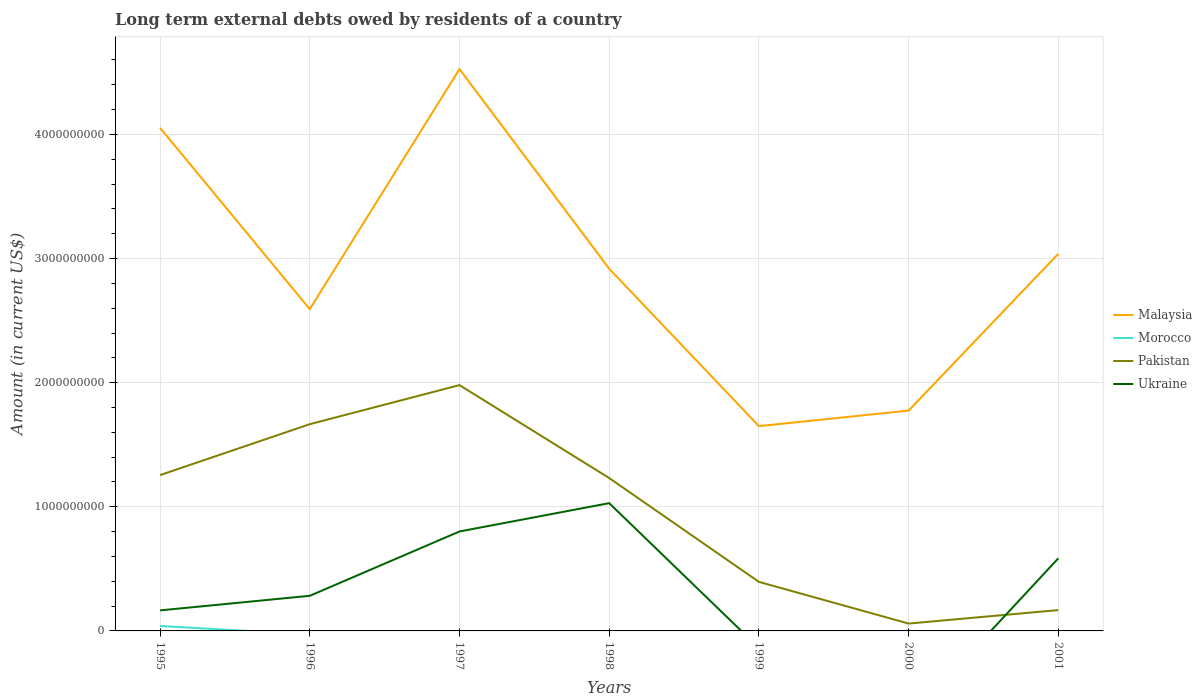Across all years, what is the maximum amount of long-term external debts owed by residents in Pakistan?
Give a very brief answer. 5.93e+07. What is the total amount of long-term external debts owed by residents in Pakistan in the graph?
Keep it short and to the point. 1.17e+09. What is the difference between the highest and the second highest amount of long-term external debts owed by residents in Ukraine?
Offer a terse response. 1.03e+09. How many years are there in the graph?
Provide a short and direct response. 7. Are the values on the major ticks of Y-axis written in scientific E-notation?
Provide a succinct answer. No. Does the graph contain any zero values?
Offer a terse response. Yes. Does the graph contain grids?
Give a very brief answer. Yes. Where does the legend appear in the graph?
Offer a terse response. Center right. What is the title of the graph?
Provide a succinct answer. Long term external debts owed by residents of a country. Does "Romania" appear as one of the legend labels in the graph?
Give a very brief answer. No. What is the Amount (in current US$) in Malaysia in 1995?
Ensure brevity in your answer.  4.05e+09. What is the Amount (in current US$) in Morocco in 1995?
Your answer should be very brief. 3.99e+07. What is the Amount (in current US$) in Pakistan in 1995?
Ensure brevity in your answer.  1.26e+09. What is the Amount (in current US$) in Ukraine in 1995?
Offer a terse response. 1.65e+08. What is the Amount (in current US$) in Malaysia in 1996?
Offer a terse response. 2.59e+09. What is the Amount (in current US$) of Morocco in 1996?
Keep it short and to the point. 0. What is the Amount (in current US$) of Pakistan in 1996?
Your answer should be compact. 1.67e+09. What is the Amount (in current US$) in Ukraine in 1996?
Your response must be concise. 2.83e+08. What is the Amount (in current US$) of Malaysia in 1997?
Give a very brief answer. 4.53e+09. What is the Amount (in current US$) of Pakistan in 1997?
Provide a succinct answer. 1.98e+09. What is the Amount (in current US$) of Ukraine in 1997?
Keep it short and to the point. 8.01e+08. What is the Amount (in current US$) of Malaysia in 1998?
Ensure brevity in your answer.  2.92e+09. What is the Amount (in current US$) in Morocco in 1998?
Make the answer very short. 0. What is the Amount (in current US$) of Pakistan in 1998?
Offer a very short reply. 1.23e+09. What is the Amount (in current US$) of Ukraine in 1998?
Provide a short and direct response. 1.03e+09. What is the Amount (in current US$) of Malaysia in 1999?
Offer a very short reply. 1.65e+09. What is the Amount (in current US$) of Pakistan in 1999?
Provide a short and direct response. 3.95e+08. What is the Amount (in current US$) of Ukraine in 1999?
Provide a short and direct response. 0. What is the Amount (in current US$) of Malaysia in 2000?
Ensure brevity in your answer.  1.78e+09. What is the Amount (in current US$) of Morocco in 2000?
Ensure brevity in your answer.  5.96e+06. What is the Amount (in current US$) in Pakistan in 2000?
Give a very brief answer. 5.93e+07. What is the Amount (in current US$) of Ukraine in 2000?
Make the answer very short. 0. What is the Amount (in current US$) in Malaysia in 2001?
Make the answer very short. 3.04e+09. What is the Amount (in current US$) of Morocco in 2001?
Your answer should be compact. 0. What is the Amount (in current US$) in Pakistan in 2001?
Your answer should be compact. 1.68e+08. What is the Amount (in current US$) in Ukraine in 2001?
Keep it short and to the point. 5.85e+08. Across all years, what is the maximum Amount (in current US$) of Malaysia?
Give a very brief answer. 4.53e+09. Across all years, what is the maximum Amount (in current US$) of Morocco?
Offer a terse response. 3.99e+07. Across all years, what is the maximum Amount (in current US$) of Pakistan?
Provide a succinct answer. 1.98e+09. Across all years, what is the maximum Amount (in current US$) in Ukraine?
Keep it short and to the point. 1.03e+09. Across all years, what is the minimum Amount (in current US$) of Malaysia?
Offer a terse response. 1.65e+09. Across all years, what is the minimum Amount (in current US$) in Pakistan?
Keep it short and to the point. 5.93e+07. Across all years, what is the minimum Amount (in current US$) of Ukraine?
Give a very brief answer. 0. What is the total Amount (in current US$) of Malaysia in the graph?
Your answer should be very brief. 2.06e+1. What is the total Amount (in current US$) of Morocco in the graph?
Provide a short and direct response. 4.59e+07. What is the total Amount (in current US$) in Pakistan in the graph?
Your answer should be very brief. 6.76e+09. What is the total Amount (in current US$) of Ukraine in the graph?
Offer a terse response. 2.86e+09. What is the difference between the Amount (in current US$) in Malaysia in 1995 and that in 1996?
Provide a succinct answer. 1.46e+09. What is the difference between the Amount (in current US$) of Pakistan in 1995 and that in 1996?
Your answer should be compact. -4.10e+08. What is the difference between the Amount (in current US$) of Ukraine in 1995 and that in 1996?
Keep it short and to the point. -1.17e+08. What is the difference between the Amount (in current US$) in Malaysia in 1995 and that in 1997?
Ensure brevity in your answer.  -4.73e+08. What is the difference between the Amount (in current US$) of Pakistan in 1995 and that in 1997?
Give a very brief answer. -7.25e+08. What is the difference between the Amount (in current US$) in Ukraine in 1995 and that in 1997?
Provide a succinct answer. -6.36e+08. What is the difference between the Amount (in current US$) in Malaysia in 1995 and that in 1998?
Keep it short and to the point. 1.14e+09. What is the difference between the Amount (in current US$) of Pakistan in 1995 and that in 1998?
Offer a terse response. 2.37e+07. What is the difference between the Amount (in current US$) in Ukraine in 1995 and that in 1998?
Your response must be concise. -8.64e+08. What is the difference between the Amount (in current US$) in Malaysia in 1995 and that in 1999?
Provide a succinct answer. 2.40e+09. What is the difference between the Amount (in current US$) in Pakistan in 1995 and that in 1999?
Provide a short and direct response. 8.60e+08. What is the difference between the Amount (in current US$) of Malaysia in 1995 and that in 2000?
Offer a very short reply. 2.28e+09. What is the difference between the Amount (in current US$) in Morocco in 1995 and that in 2000?
Offer a terse response. 3.40e+07. What is the difference between the Amount (in current US$) in Pakistan in 1995 and that in 2000?
Offer a terse response. 1.20e+09. What is the difference between the Amount (in current US$) in Malaysia in 1995 and that in 2001?
Keep it short and to the point. 1.01e+09. What is the difference between the Amount (in current US$) of Pakistan in 1995 and that in 2001?
Provide a succinct answer. 1.09e+09. What is the difference between the Amount (in current US$) of Ukraine in 1995 and that in 2001?
Offer a terse response. -4.19e+08. What is the difference between the Amount (in current US$) in Malaysia in 1996 and that in 1997?
Your answer should be compact. -1.93e+09. What is the difference between the Amount (in current US$) in Pakistan in 1996 and that in 1997?
Your response must be concise. -3.15e+08. What is the difference between the Amount (in current US$) of Ukraine in 1996 and that in 1997?
Offer a terse response. -5.18e+08. What is the difference between the Amount (in current US$) of Malaysia in 1996 and that in 1998?
Keep it short and to the point. -3.25e+08. What is the difference between the Amount (in current US$) of Pakistan in 1996 and that in 1998?
Provide a short and direct response. 4.34e+08. What is the difference between the Amount (in current US$) in Ukraine in 1996 and that in 1998?
Provide a short and direct response. -7.46e+08. What is the difference between the Amount (in current US$) in Malaysia in 1996 and that in 1999?
Offer a very short reply. 9.43e+08. What is the difference between the Amount (in current US$) of Pakistan in 1996 and that in 1999?
Give a very brief answer. 1.27e+09. What is the difference between the Amount (in current US$) of Malaysia in 1996 and that in 2000?
Your answer should be very brief. 8.18e+08. What is the difference between the Amount (in current US$) of Pakistan in 1996 and that in 2000?
Offer a very short reply. 1.61e+09. What is the difference between the Amount (in current US$) of Malaysia in 1996 and that in 2001?
Make the answer very short. -4.46e+08. What is the difference between the Amount (in current US$) in Pakistan in 1996 and that in 2001?
Your answer should be very brief. 1.50e+09. What is the difference between the Amount (in current US$) in Ukraine in 1996 and that in 2001?
Give a very brief answer. -3.02e+08. What is the difference between the Amount (in current US$) in Malaysia in 1997 and that in 1998?
Provide a succinct answer. 1.61e+09. What is the difference between the Amount (in current US$) of Pakistan in 1997 and that in 1998?
Keep it short and to the point. 7.49e+08. What is the difference between the Amount (in current US$) in Ukraine in 1997 and that in 1998?
Your answer should be compact. -2.28e+08. What is the difference between the Amount (in current US$) of Malaysia in 1997 and that in 1999?
Ensure brevity in your answer.  2.88e+09. What is the difference between the Amount (in current US$) in Pakistan in 1997 and that in 1999?
Provide a succinct answer. 1.59e+09. What is the difference between the Amount (in current US$) of Malaysia in 1997 and that in 2000?
Offer a terse response. 2.75e+09. What is the difference between the Amount (in current US$) of Pakistan in 1997 and that in 2000?
Offer a terse response. 1.92e+09. What is the difference between the Amount (in current US$) of Malaysia in 1997 and that in 2001?
Your answer should be very brief. 1.49e+09. What is the difference between the Amount (in current US$) of Pakistan in 1997 and that in 2001?
Your answer should be very brief. 1.81e+09. What is the difference between the Amount (in current US$) of Ukraine in 1997 and that in 2001?
Ensure brevity in your answer.  2.16e+08. What is the difference between the Amount (in current US$) of Malaysia in 1998 and that in 1999?
Provide a short and direct response. 1.27e+09. What is the difference between the Amount (in current US$) in Pakistan in 1998 and that in 1999?
Your answer should be compact. 8.37e+08. What is the difference between the Amount (in current US$) in Malaysia in 1998 and that in 2000?
Offer a terse response. 1.14e+09. What is the difference between the Amount (in current US$) of Pakistan in 1998 and that in 2000?
Ensure brevity in your answer.  1.17e+09. What is the difference between the Amount (in current US$) in Malaysia in 1998 and that in 2001?
Your answer should be compact. -1.20e+08. What is the difference between the Amount (in current US$) in Pakistan in 1998 and that in 2001?
Provide a succinct answer. 1.06e+09. What is the difference between the Amount (in current US$) of Ukraine in 1998 and that in 2001?
Your answer should be very brief. 4.44e+08. What is the difference between the Amount (in current US$) of Malaysia in 1999 and that in 2000?
Offer a very short reply. -1.25e+08. What is the difference between the Amount (in current US$) in Pakistan in 1999 and that in 2000?
Ensure brevity in your answer.  3.36e+08. What is the difference between the Amount (in current US$) of Malaysia in 1999 and that in 2001?
Provide a succinct answer. -1.39e+09. What is the difference between the Amount (in current US$) in Pakistan in 1999 and that in 2001?
Your answer should be very brief. 2.27e+08. What is the difference between the Amount (in current US$) of Malaysia in 2000 and that in 2001?
Provide a short and direct response. -1.26e+09. What is the difference between the Amount (in current US$) of Pakistan in 2000 and that in 2001?
Make the answer very short. -1.08e+08. What is the difference between the Amount (in current US$) of Malaysia in 1995 and the Amount (in current US$) of Pakistan in 1996?
Keep it short and to the point. 2.39e+09. What is the difference between the Amount (in current US$) of Malaysia in 1995 and the Amount (in current US$) of Ukraine in 1996?
Make the answer very short. 3.77e+09. What is the difference between the Amount (in current US$) of Morocco in 1995 and the Amount (in current US$) of Pakistan in 1996?
Provide a succinct answer. -1.63e+09. What is the difference between the Amount (in current US$) in Morocco in 1995 and the Amount (in current US$) in Ukraine in 1996?
Offer a very short reply. -2.43e+08. What is the difference between the Amount (in current US$) of Pakistan in 1995 and the Amount (in current US$) of Ukraine in 1996?
Provide a short and direct response. 9.73e+08. What is the difference between the Amount (in current US$) of Malaysia in 1995 and the Amount (in current US$) of Pakistan in 1997?
Offer a terse response. 2.07e+09. What is the difference between the Amount (in current US$) in Malaysia in 1995 and the Amount (in current US$) in Ukraine in 1997?
Your answer should be compact. 3.25e+09. What is the difference between the Amount (in current US$) in Morocco in 1995 and the Amount (in current US$) in Pakistan in 1997?
Ensure brevity in your answer.  -1.94e+09. What is the difference between the Amount (in current US$) in Morocco in 1995 and the Amount (in current US$) in Ukraine in 1997?
Provide a short and direct response. -7.61e+08. What is the difference between the Amount (in current US$) of Pakistan in 1995 and the Amount (in current US$) of Ukraine in 1997?
Give a very brief answer. 4.54e+08. What is the difference between the Amount (in current US$) in Malaysia in 1995 and the Amount (in current US$) in Pakistan in 1998?
Ensure brevity in your answer.  2.82e+09. What is the difference between the Amount (in current US$) of Malaysia in 1995 and the Amount (in current US$) of Ukraine in 1998?
Your response must be concise. 3.02e+09. What is the difference between the Amount (in current US$) of Morocco in 1995 and the Amount (in current US$) of Pakistan in 1998?
Offer a terse response. -1.19e+09. What is the difference between the Amount (in current US$) of Morocco in 1995 and the Amount (in current US$) of Ukraine in 1998?
Make the answer very short. -9.89e+08. What is the difference between the Amount (in current US$) of Pakistan in 1995 and the Amount (in current US$) of Ukraine in 1998?
Offer a terse response. 2.26e+08. What is the difference between the Amount (in current US$) of Malaysia in 1995 and the Amount (in current US$) of Pakistan in 1999?
Your response must be concise. 3.66e+09. What is the difference between the Amount (in current US$) of Morocco in 1995 and the Amount (in current US$) of Pakistan in 1999?
Your response must be concise. -3.55e+08. What is the difference between the Amount (in current US$) of Malaysia in 1995 and the Amount (in current US$) of Morocco in 2000?
Your answer should be compact. 4.05e+09. What is the difference between the Amount (in current US$) in Malaysia in 1995 and the Amount (in current US$) in Pakistan in 2000?
Offer a very short reply. 3.99e+09. What is the difference between the Amount (in current US$) of Morocco in 1995 and the Amount (in current US$) of Pakistan in 2000?
Your answer should be compact. -1.94e+07. What is the difference between the Amount (in current US$) of Malaysia in 1995 and the Amount (in current US$) of Pakistan in 2001?
Your answer should be compact. 3.89e+09. What is the difference between the Amount (in current US$) in Malaysia in 1995 and the Amount (in current US$) in Ukraine in 2001?
Provide a succinct answer. 3.47e+09. What is the difference between the Amount (in current US$) in Morocco in 1995 and the Amount (in current US$) in Pakistan in 2001?
Ensure brevity in your answer.  -1.28e+08. What is the difference between the Amount (in current US$) in Morocco in 1995 and the Amount (in current US$) in Ukraine in 2001?
Give a very brief answer. -5.45e+08. What is the difference between the Amount (in current US$) in Pakistan in 1995 and the Amount (in current US$) in Ukraine in 2001?
Keep it short and to the point. 6.71e+08. What is the difference between the Amount (in current US$) of Malaysia in 1996 and the Amount (in current US$) of Pakistan in 1997?
Keep it short and to the point. 6.12e+08. What is the difference between the Amount (in current US$) of Malaysia in 1996 and the Amount (in current US$) of Ukraine in 1997?
Ensure brevity in your answer.  1.79e+09. What is the difference between the Amount (in current US$) of Pakistan in 1996 and the Amount (in current US$) of Ukraine in 1997?
Make the answer very short. 8.64e+08. What is the difference between the Amount (in current US$) of Malaysia in 1996 and the Amount (in current US$) of Pakistan in 1998?
Make the answer very short. 1.36e+09. What is the difference between the Amount (in current US$) in Malaysia in 1996 and the Amount (in current US$) in Ukraine in 1998?
Your answer should be very brief. 1.56e+09. What is the difference between the Amount (in current US$) of Pakistan in 1996 and the Amount (in current US$) of Ukraine in 1998?
Make the answer very short. 6.36e+08. What is the difference between the Amount (in current US$) of Malaysia in 1996 and the Amount (in current US$) of Pakistan in 1999?
Offer a terse response. 2.20e+09. What is the difference between the Amount (in current US$) of Malaysia in 1996 and the Amount (in current US$) of Morocco in 2000?
Offer a terse response. 2.59e+09. What is the difference between the Amount (in current US$) of Malaysia in 1996 and the Amount (in current US$) of Pakistan in 2000?
Your answer should be very brief. 2.53e+09. What is the difference between the Amount (in current US$) of Malaysia in 1996 and the Amount (in current US$) of Pakistan in 2001?
Keep it short and to the point. 2.42e+09. What is the difference between the Amount (in current US$) in Malaysia in 1996 and the Amount (in current US$) in Ukraine in 2001?
Ensure brevity in your answer.  2.01e+09. What is the difference between the Amount (in current US$) in Pakistan in 1996 and the Amount (in current US$) in Ukraine in 2001?
Provide a succinct answer. 1.08e+09. What is the difference between the Amount (in current US$) in Malaysia in 1997 and the Amount (in current US$) in Pakistan in 1998?
Provide a short and direct response. 3.29e+09. What is the difference between the Amount (in current US$) in Malaysia in 1997 and the Amount (in current US$) in Ukraine in 1998?
Make the answer very short. 3.50e+09. What is the difference between the Amount (in current US$) in Pakistan in 1997 and the Amount (in current US$) in Ukraine in 1998?
Your answer should be compact. 9.51e+08. What is the difference between the Amount (in current US$) in Malaysia in 1997 and the Amount (in current US$) in Pakistan in 1999?
Your answer should be compact. 4.13e+09. What is the difference between the Amount (in current US$) in Malaysia in 1997 and the Amount (in current US$) in Morocco in 2000?
Offer a terse response. 4.52e+09. What is the difference between the Amount (in current US$) in Malaysia in 1997 and the Amount (in current US$) in Pakistan in 2000?
Offer a very short reply. 4.47e+09. What is the difference between the Amount (in current US$) of Malaysia in 1997 and the Amount (in current US$) of Pakistan in 2001?
Provide a succinct answer. 4.36e+09. What is the difference between the Amount (in current US$) in Malaysia in 1997 and the Amount (in current US$) in Ukraine in 2001?
Offer a terse response. 3.94e+09. What is the difference between the Amount (in current US$) of Pakistan in 1997 and the Amount (in current US$) of Ukraine in 2001?
Offer a very short reply. 1.40e+09. What is the difference between the Amount (in current US$) in Malaysia in 1998 and the Amount (in current US$) in Pakistan in 1999?
Your response must be concise. 2.52e+09. What is the difference between the Amount (in current US$) in Malaysia in 1998 and the Amount (in current US$) in Morocco in 2000?
Offer a terse response. 2.91e+09. What is the difference between the Amount (in current US$) in Malaysia in 1998 and the Amount (in current US$) in Pakistan in 2000?
Give a very brief answer. 2.86e+09. What is the difference between the Amount (in current US$) of Malaysia in 1998 and the Amount (in current US$) of Pakistan in 2001?
Your answer should be compact. 2.75e+09. What is the difference between the Amount (in current US$) of Malaysia in 1998 and the Amount (in current US$) of Ukraine in 2001?
Your answer should be very brief. 2.33e+09. What is the difference between the Amount (in current US$) in Pakistan in 1998 and the Amount (in current US$) in Ukraine in 2001?
Make the answer very short. 6.47e+08. What is the difference between the Amount (in current US$) in Malaysia in 1999 and the Amount (in current US$) in Morocco in 2000?
Offer a very short reply. 1.64e+09. What is the difference between the Amount (in current US$) in Malaysia in 1999 and the Amount (in current US$) in Pakistan in 2000?
Provide a succinct answer. 1.59e+09. What is the difference between the Amount (in current US$) of Malaysia in 1999 and the Amount (in current US$) of Pakistan in 2001?
Provide a short and direct response. 1.48e+09. What is the difference between the Amount (in current US$) of Malaysia in 1999 and the Amount (in current US$) of Ukraine in 2001?
Ensure brevity in your answer.  1.06e+09. What is the difference between the Amount (in current US$) of Pakistan in 1999 and the Amount (in current US$) of Ukraine in 2001?
Offer a very short reply. -1.90e+08. What is the difference between the Amount (in current US$) of Malaysia in 2000 and the Amount (in current US$) of Pakistan in 2001?
Offer a very short reply. 1.61e+09. What is the difference between the Amount (in current US$) of Malaysia in 2000 and the Amount (in current US$) of Ukraine in 2001?
Keep it short and to the point. 1.19e+09. What is the difference between the Amount (in current US$) of Morocco in 2000 and the Amount (in current US$) of Pakistan in 2001?
Offer a very short reply. -1.62e+08. What is the difference between the Amount (in current US$) in Morocco in 2000 and the Amount (in current US$) in Ukraine in 2001?
Provide a short and direct response. -5.79e+08. What is the difference between the Amount (in current US$) in Pakistan in 2000 and the Amount (in current US$) in Ukraine in 2001?
Give a very brief answer. -5.26e+08. What is the average Amount (in current US$) of Malaysia per year?
Your response must be concise. 2.94e+09. What is the average Amount (in current US$) of Morocco per year?
Keep it short and to the point. 6.55e+06. What is the average Amount (in current US$) of Pakistan per year?
Your answer should be compact. 9.65e+08. What is the average Amount (in current US$) in Ukraine per year?
Provide a succinct answer. 4.09e+08. In the year 1995, what is the difference between the Amount (in current US$) in Malaysia and Amount (in current US$) in Morocco?
Give a very brief answer. 4.01e+09. In the year 1995, what is the difference between the Amount (in current US$) in Malaysia and Amount (in current US$) in Pakistan?
Provide a succinct answer. 2.80e+09. In the year 1995, what is the difference between the Amount (in current US$) of Malaysia and Amount (in current US$) of Ukraine?
Offer a terse response. 3.89e+09. In the year 1995, what is the difference between the Amount (in current US$) in Morocco and Amount (in current US$) in Pakistan?
Offer a terse response. -1.22e+09. In the year 1995, what is the difference between the Amount (in current US$) in Morocco and Amount (in current US$) in Ukraine?
Your response must be concise. -1.26e+08. In the year 1995, what is the difference between the Amount (in current US$) of Pakistan and Amount (in current US$) of Ukraine?
Provide a short and direct response. 1.09e+09. In the year 1996, what is the difference between the Amount (in current US$) of Malaysia and Amount (in current US$) of Pakistan?
Ensure brevity in your answer.  9.27e+08. In the year 1996, what is the difference between the Amount (in current US$) in Malaysia and Amount (in current US$) in Ukraine?
Give a very brief answer. 2.31e+09. In the year 1996, what is the difference between the Amount (in current US$) of Pakistan and Amount (in current US$) of Ukraine?
Give a very brief answer. 1.38e+09. In the year 1997, what is the difference between the Amount (in current US$) in Malaysia and Amount (in current US$) in Pakistan?
Provide a succinct answer. 2.55e+09. In the year 1997, what is the difference between the Amount (in current US$) of Malaysia and Amount (in current US$) of Ukraine?
Your answer should be very brief. 3.73e+09. In the year 1997, what is the difference between the Amount (in current US$) in Pakistan and Amount (in current US$) in Ukraine?
Give a very brief answer. 1.18e+09. In the year 1998, what is the difference between the Amount (in current US$) of Malaysia and Amount (in current US$) of Pakistan?
Offer a very short reply. 1.69e+09. In the year 1998, what is the difference between the Amount (in current US$) in Malaysia and Amount (in current US$) in Ukraine?
Give a very brief answer. 1.89e+09. In the year 1998, what is the difference between the Amount (in current US$) of Pakistan and Amount (in current US$) of Ukraine?
Offer a very short reply. 2.02e+08. In the year 1999, what is the difference between the Amount (in current US$) of Malaysia and Amount (in current US$) of Pakistan?
Your answer should be very brief. 1.25e+09. In the year 2000, what is the difference between the Amount (in current US$) in Malaysia and Amount (in current US$) in Morocco?
Provide a succinct answer. 1.77e+09. In the year 2000, what is the difference between the Amount (in current US$) in Malaysia and Amount (in current US$) in Pakistan?
Your answer should be compact. 1.72e+09. In the year 2000, what is the difference between the Amount (in current US$) in Morocco and Amount (in current US$) in Pakistan?
Provide a succinct answer. -5.34e+07. In the year 2001, what is the difference between the Amount (in current US$) in Malaysia and Amount (in current US$) in Pakistan?
Ensure brevity in your answer.  2.87e+09. In the year 2001, what is the difference between the Amount (in current US$) of Malaysia and Amount (in current US$) of Ukraine?
Make the answer very short. 2.45e+09. In the year 2001, what is the difference between the Amount (in current US$) in Pakistan and Amount (in current US$) in Ukraine?
Offer a terse response. -4.17e+08. What is the ratio of the Amount (in current US$) of Malaysia in 1995 to that in 1996?
Your response must be concise. 1.56. What is the ratio of the Amount (in current US$) of Pakistan in 1995 to that in 1996?
Your answer should be very brief. 0.75. What is the ratio of the Amount (in current US$) of Ukraine in 1995 to that in 1996?
Offer a very short reply. 0.58. What is the ratio of the Amount (in current US$) in Malaysia in 1995 to that in 1997?
Ensure brevity in your answer.  0.9. What is the ratio of the Amount (in current US$) of Pakistan in 1995 to that in 1997?
Offer a terse response. 0.63. What is the ratio of the Amount (in current US$) in Ukraine in 1995 to that in 1997?
Provide a succinct answer. 0.21. What is the ratio of the Amount (in current US$) of Malaysia in 1995 to that in 1998?
Make the answer very short. 1.39. What is the ratio of the Amount (in current US$) in Pakistan in 1995 to that in 1998?
Your answer should be compact. 1.02. What is the ratio of the Amount (in current US$) of Ukraine in 1995 to that in 1998?
Give a very brief answer. 0.16. What is the ratio of the Amount (in current US$) of Malaysia in 1995 to that in 1999?
Ensure brevity in your answer.  2.46. What is the ratio of the Amount (in current US$) in Pakistan in 1995 to that in 1999?
Give a very brief answer. 3.18. What is the ratio of the Amount (in current US$) in Malaysia in 1995 to that in 2000?
Provide a succinct answer. 2.28. What is the ratio of the Amount (in current US$) in Morocco in 1995 to that in 2000?
Ensure brevity in your answer.  6.7. What is the ratio of the Amount (in current US$) in Pakistan in 1995 to that in 2000?
Your answer should be very brief. 21.17. What is the ratio of the Amount (in current US$) of Malaysia in 1995 to that in 2001?
Offer a terse response. 1.33. What is the ratio of the Amount (in current US$) in Pakistan in 1995 to that in 2001?
Keep it short and to the point. 7.48. What is the ratio of the Amount (in current US$) of Ukraine in 1995 to that in 2001?
Offer a very short reply. 0.28. What is the ratio of the Amount (in current US$) in Malaysia in 1996 to that in 1997?
Your answer should be compact. 0.57. What is the ratio of the Amount (in current US$) in Pakistan in 1996 to that in 1997?
Offer a very short reply. 0.84. What is the ratio of the Amount (in current US$) of Ukraine in 1996 to that in 1997?
Your answer should be very brief. 0.35. What is the ratio of the Amount (in current US$) in Malaysia in 1996 to that in 1998?
Provide a short and direct response. 0.89. What is the ratio of the Amount (in current US$) of Pakistan in 1996 to that in 1998?
Offer a terse response. 1.35. What is the ratio of the Amount (in current US$) of Ukraine in 1996 to that in 1998?
Offer a terse response. 0.27. What is the ratio of the Amount (in current US$) in Malaysia in 1996 to that in 1999?
Keep it short and to the point. 1.57. What is the ratio of the Amount (in current US$) of Pakistan in 1996 to that in 1999?
Make the answer very short. 4.21. What is the ratio of the Amount (in current US$) in Malaysia in 1996 to that in 2000?
Your response must be concise. 1.46. What is the ratio of the Amount (in current US$) of Pakistan in 1996 to that in 2000?
Make the answer very short. 28.08. What is the ratio of the Amount (in current US$) of Malaysia in 1996 to that in 2001?
Your response must be concise. 0.85. What is the ratio of the Amount (in current US$) of Pakistan in 1996 to that in 2001?
Provide a succinct answer. 9.93. What is the ratio of the Amount (in current US$) in Ukraine in 1996 to that in 2001?
Keep it short and to the point. 0.48. What is the ratio of the Amount (in current US$) in Malaysia in 1997 to that in 1998?
Ensure brevity in your answer.  1.55. What is the ratio of the Amount (in current US$) in Pakistan in 1997 to that in 1998?
Ensure brevity in your answer.  1.61. What is the ratio of the Amount (in current US$) of Ukraine in 1997 to that in 1998?
Make the answer very short. 0.78. What is the ratio of the Amount (in current US$) in Malaysia in 1997 to that in 1999?
Provide a succinct answer. 2.74. What is the ratio of the Amount (in current US$) of Pakistan in 1997 to that in 1999?
Your answer should be very brief. 5.01. What is the ratio of the Amount (in current US$) in Malaysia in 1997 to that in 2000?
Your response must be concise. 2.55. What is the ratio of the Amount (in current US$) in Pakistan in 1997 to that in 2000?
Offer a very short reply. 33.39. What is the ratio of the Amount (in current US$) of Malaysia in 1997 to that in 2001?
Ensure brevity in your answer.  1.49. What is the ratio of the Amount (in current US$) in Pakistan in 1997 to that in 2001?
Give a very brief answer. 11.8. What is the ratio of the Amount (in current US$) of Ukraine in 1997 to that in 2001?
Offer a terse response. 1.37. What is the ratio of the Amount (in current US$) of Malaysia in 1998 to that in 1999?
Provide a short and direct response. 1.77. What is the ratio of the Amount (in current US$) in Pakistan in 1998 to that in 1999?
Your answer should be compact. 3.12. What is the ratio of the Amount (in current US$) in Malaysia in 1998 to that in 2000?
Your answer should be very brief. 1.64. What is the ratio of the Amount (in current US$) of Pakistan in 1998 to that in 2000?
Make the answer very short. 20.77. What is the ratio of the Amount (in current US$) in Malaysia in 1998 to that in 2001?
Your answer should be compact. 0.96. What is the ratio of the Amount (in current US$) in Pakistan in 1998 to that in 2001?
Provide a succinct answer. 7.34. What is the ratio of the Amount (in current US$) in Ukraine in 1998 to that in 2001?
Provide a short and direct response. 1.76. What is the ratio of the Amount (in current US$) of Malaysia in 1999 to that in 2000?
Provide a short and direct response. 0.93. What is the ratio of the Amount (in current US$) in Pakistan in 1999 to that in 2000?
Provide a short and direct response. 6.66. What is the ratio of the Amount (in current US$) in Malaysia in 1999 to that in 2001?
Your response must be concise. 0.54. What is the ratio of the Amount (in current US$) in Pakistan in 1999 to that in 2001?
Your answer should be very brief. 2.36. What is the ratio of the Amount (in current US$) in Malaysia in 2000 to that in 2001?
Provide a succinct answer. 0.58. What is the ratio of the Amount (in current US$) of Pakistan in 2000 to that in 2001?
Keep it short and to the point. 0.35. What is the difference between the highest and the second highest Amount (in current US$) in Malaysia?
Keep it short and to the point. 4.73e+08. What is the difference between the highest and the second highest Amount (in current US$) in Pakistan?
Offer a very short reply. 3.15e+08. What is the difference between the highest and the second highest Amount (in current US$) in Ukraine?
Make the answer very short. 2.28e+08. What is the difference between the highest and the lowest Amount (in current US$) of Malaysia?
Offer a terse response. 2.88e+09. What is the difference between the highest and the lowest Amount (in current US$) in Morocco?
Offer a very short reply. 3.99e+07. What is the difference between the highest and the lowest Amount (in current US$) in Pakistan?
Your response must be concise. 1.92e+09. What is the difference between the highest and the lowest Amount (in current US$) of Ukraine?
Offer a very short reply. 1.03e+09. 